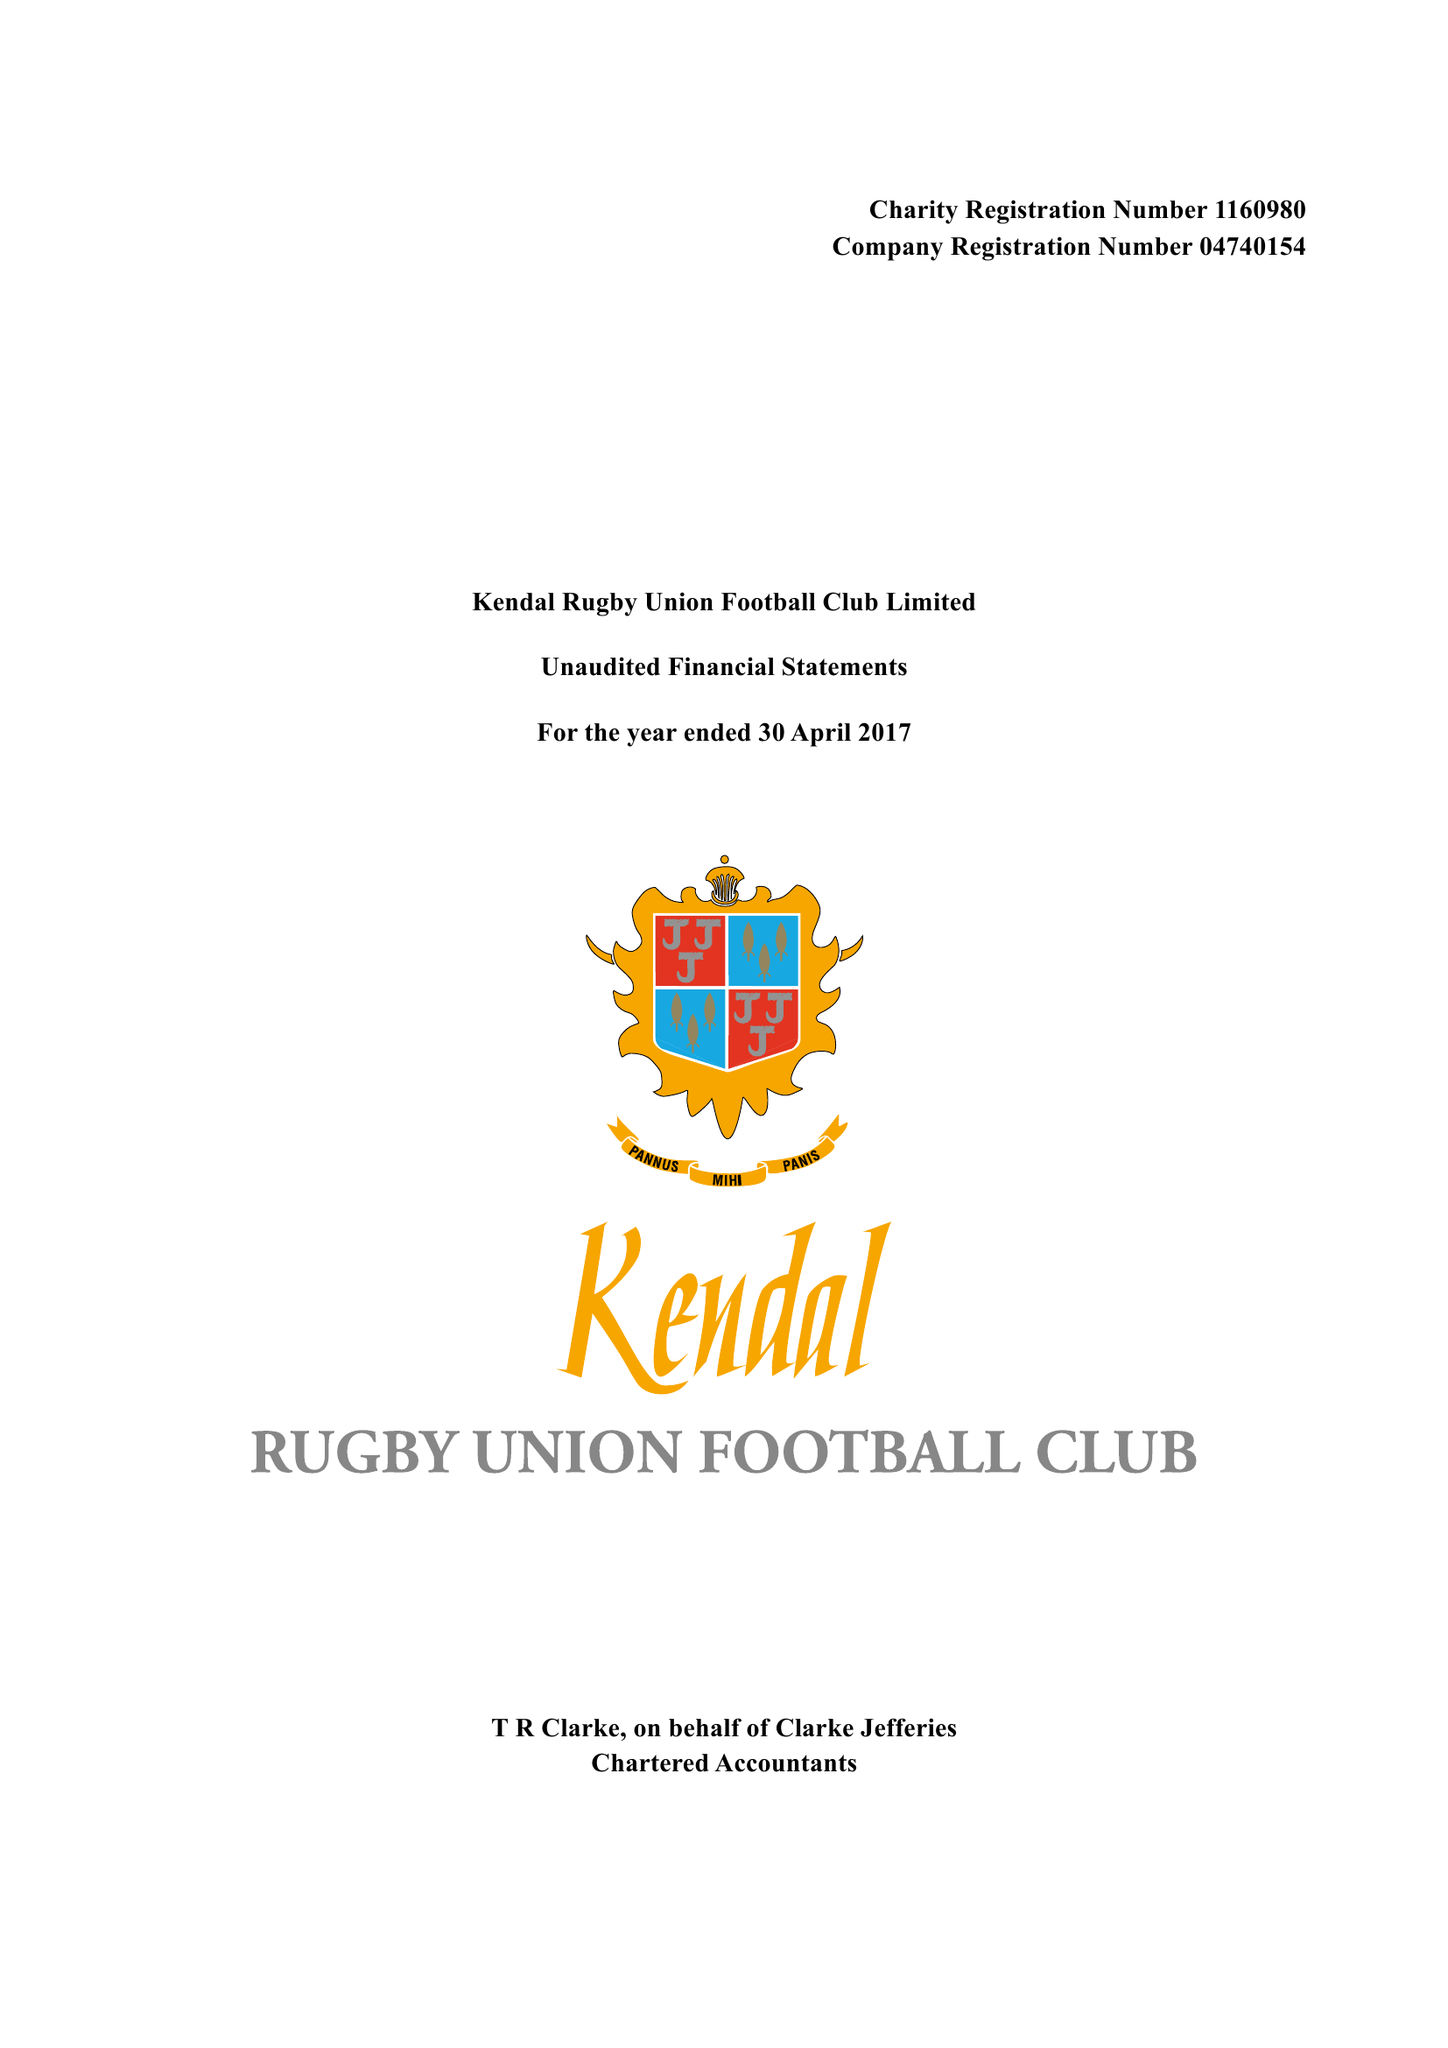What is the value for the income_annually_in_british_pounds?
Answer the question using a single word or phrase. 92441.00 